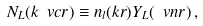Convert formula to latex. <formula><loc_0><loc_0><loc_500><loc_500>N _ { L } ( k \ v c r ) \equiv n _ { l } ( k r ) Y _ { L } ( \ v n r ) \, ,</formula> 